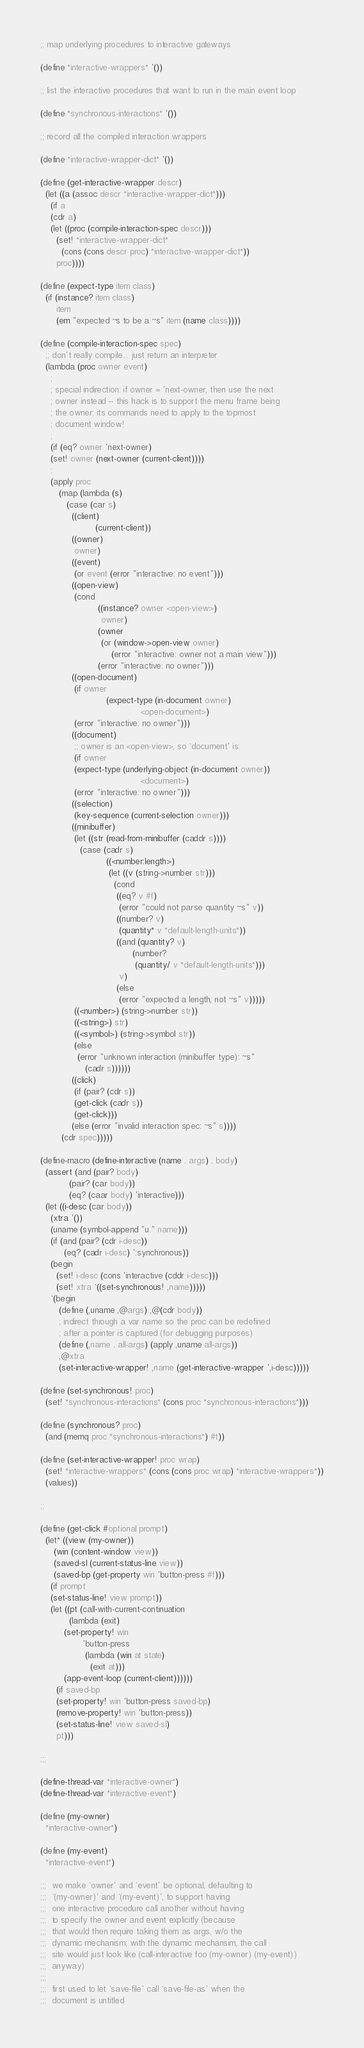Convert code to text. <code><loc_0><loc_0><loc_500><loc_500><_Scheme_>
;; map underlying procedures to interactive gateways

(define *interactive-wrappers* '())

;; list the interactive procedures that want to run in the main event loop

(define *synchronous-interactions* '())

;; record all the compiled interaction wrappers

(define *interactive-wrapper-dict* '())

(define (get-interactive-wrapper descr)
  (let ((a (assoc descr *interactive-wrapper-dict*)))
    (if a
	(cdr a)
	(let ((proc (compile-interaction-spec descr)))
	  (set! *interactive-wrapper-dict*
		(cons (cons descr proc) *interactive-wrapper-dict*))
	  proc))))

(define (expect-type item class)
  (if (instance? item class)
      item
      (em "expected ~s to be a ~s" item (name class))))

(define (compile-interaction-spec spec)
  ;; don't really compile... just return an interpreter
  (lambda (proc owner event)
    ;
    ; special indirection: if owner = 'next-owner, then use the next
    ; owner instead -- this hack is to support the menu frame being
    ; the owner; its commands need to apply to the topmost
    ; document window!
    ;
    (if (eq? owner 'next-owner)
	(set! owner (next-owner (current-client))))
    ;
    (apply proc
	   (map (lambda (s)
		  (case (car s)
		    ((client) 
                     (current-client))
		    ((owner)
		     owner)
		    ((event)
		     (or event (error "interactive: no event")))
		    ((open-view)
		     (cond
                      ((instance? owner <open-view>)
                       owner)
                      (owner
                       (or (window->open-view owner)
                           (error "interactive: owner not a main view")))
                      (error "interactive: no owner")))
		    ((open-document)
		     (if owner
                         (expect-type (in-document owner)
                                      <open-document>)
			 (error "interactive: no owner")))
		    ((document)
		     ;; owner is an <open-view>, so `document' is:
		     (if owner
			 (expect-type (underlying-object (in-document owner))
                                      <document>)
			 (error "interactive: no owner")))
		    ((selection)
		     (key-sequence (current-selection owner)))
		    ((minibuffer)
		     (let ((str (read-from-minibuffer (caddr s))))
		       (case (cadr s)
                         ((<number:length>) 
                          (let ((v (string->number str)))
                            (cond
                             ((eq? v #f)
                              (error "could not parse quantity ~s" v))
                             ((number? v)
                              (quantity* v *default-length-units*))
                             ((and (quantity? v)
                                   (number? 
                                    (quantity/ v *default-length-units*)))
                              v)
                             (else
                              (error "expected a length, not ~s" v)))))
			 ((<number>) (string->number str))
			 ((<string>) str)
			 ((<symbol>) (string->symbol str))
			 (else
			  (error "unknown interaction (minibuffer type): ~s"
				 (cadr s))))))
		    ((click)
		     (if (pair? (cdr s))
			 (get-click (cadr s))
			 (get-click)))
		    (else (error "invalid interaction spec: ~s" s))))
		(cdr spec)))))
  
(define-macro (define-interactive (name . args) . body)
  (assert (and (pair? body)
	       (pair? (car body))
	       (eq? (caar body) 'interactive)))
  (let ((i-desc (car body))
	(xtra '())
	(uname (symbol-append "u." name)))
    (if (and (pair? (cdr i-desc))
	     (eq? (cadr i-desc) ':synchronous))
	(begin
	  (set! i-desc (cons 'interactive (cddr i-desc)))
	  (set! xtra `((set-synchronous! ,name)))))
    `(begin
       (define (,uname ,@args) ,@(cdr body))
       ; indirect through a var name so the proc can be redefined
       ; after a pointer is captured (for debugging purposes)
       (define (,name . all-args) (apply ,uname all-args))
       ,@xtra
       (set-interactive-wrapper! ,name (get-interactive-wrapper ',i-desc)))))

(define (set-synchronous! proc)
  (set! *synchronous-interactions* (cons proc *synchronous-interactions*)))

(define (synchronous? proc)
  (and (memq proc *synchronous-interactions*) #t))

(define (set-interactive-wrapper! proc wrap)
  (set! *interactive-wrappers* (cons (cons proc wrap) *interactive-wrappers*))
  (values))

;;

(define (get-click #optional prompt)
  (let* ((view (my-owner))
	 (win (content-window view))
	 (saved-sl (current-status-line view))
	 (saved-bp (get-property win 'button-press #f)))
    (if prompt
	(set-status-line! view prompt))
    (let ((pt (call-with-current-continuation
	       (lambda (exit)
		 (set-property! win
				'button-press 
				 (lambda (win at state)
				   (exit at)))
		 (app-event-loop (current-client))))))
      (if saved-bp
	  (set-property! win 'button-press saved-bp)
	  (remove-property! win 'button-press))
      (set-status-line! view saved-sl)
      pt)))
				 
;;;

(define-thread-var *interactive-owner*)
(define-thread-var *interactive-event*)

(define (my-owner)
  *interactive-owner*)

(define (my-event)
  *interactive-event*)

;;;  we make `owner' and `event' be optional, defaulting to
;;;  `(my-owner)' and `(my-event)', to support having
;;;  one interactive procedure call another without having
;;;  to specify the owner and event explicitly (because
;;;  that would then require taking them as args, w/o the
;;;  dynamic mechanism; with the dynamic mechansim, the call
;;;  site would just look like (call-interactive foo (my-owner) (my-event))
;;;  anyway)
;;;
;;;  first used to let `save-file' call `save-file-as' when the
;;;  document is untitled
</code> 